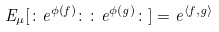<formula> <loc_0><loc_0><loc_500><loc_500>E _ { \mu } [ \colon e ^ { \phi ( f ) } \colon \colon e ^ { \phi ( g ) } \colon ] = e ^ { \langle f , g \rangle }</formula> 